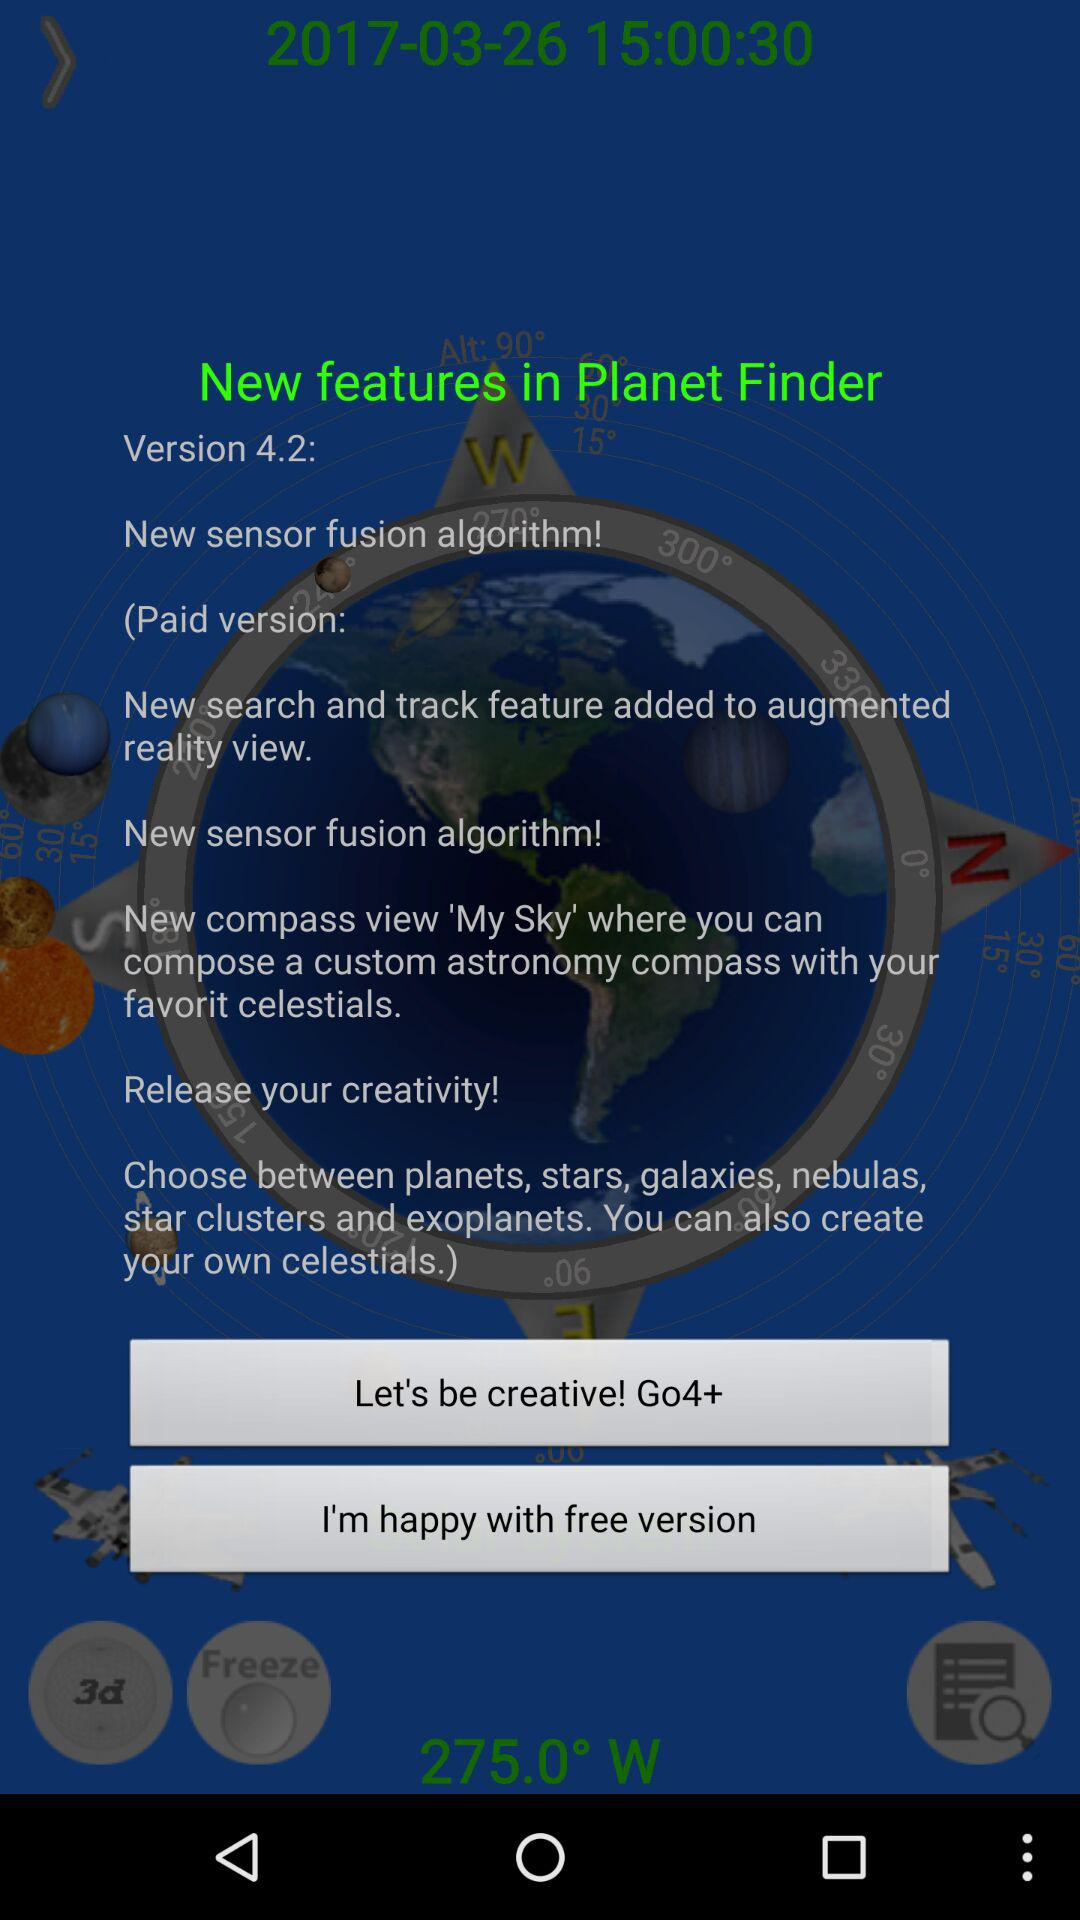How many degrees off of north is the compass pointing?
Answer the question using a single word or phrase. 275.0° 